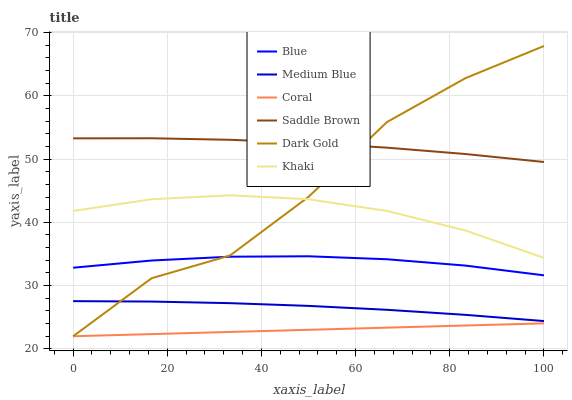Does Coral have the minimum area under the curve?
Answer yes or no. Yes. Does Saddle Brown have the maximum area under the curve?
Answer yes or no. Yes. Does Khaki have the minimum area under the curve?
Answer yes or no. No. Does Khaki have the maximum area under the curve?
Answer yes or no. No. Is Coral the smoothest?
Answer yes or no. Yes. Is Dark Gold the roughest?
Answer yes or no. Yes. Is Khaki the smoothest?
Answer yes or no. No. Is Khaki the roughest?
Answer yes or no. No. Does Dark Gold have the lowest value?
Answer yes or no. Yes. Does Khaki have the lowest value?
Answer yes or no. No. Does Dark Gold have the highest value?
Answer yes or no. Yes. Does Khaki have the highest value?
Answer yes or no. No. Is Medium Blue less than Saddle Brown?
Answer yes or no. Yes. Is Saddle Brown greater than Khaki?
Answer yes or no. Yes. Does Dark Gold intersect Coral?
Answer yes or no. Yes. Is Dark Gold less than Coral?
Answer yes or no. No. Is Dark Gold greater than Coral?
Answer yes or no. No. Does Medium Blue intersect Saddle Brown?
Answer yes or no. No. 